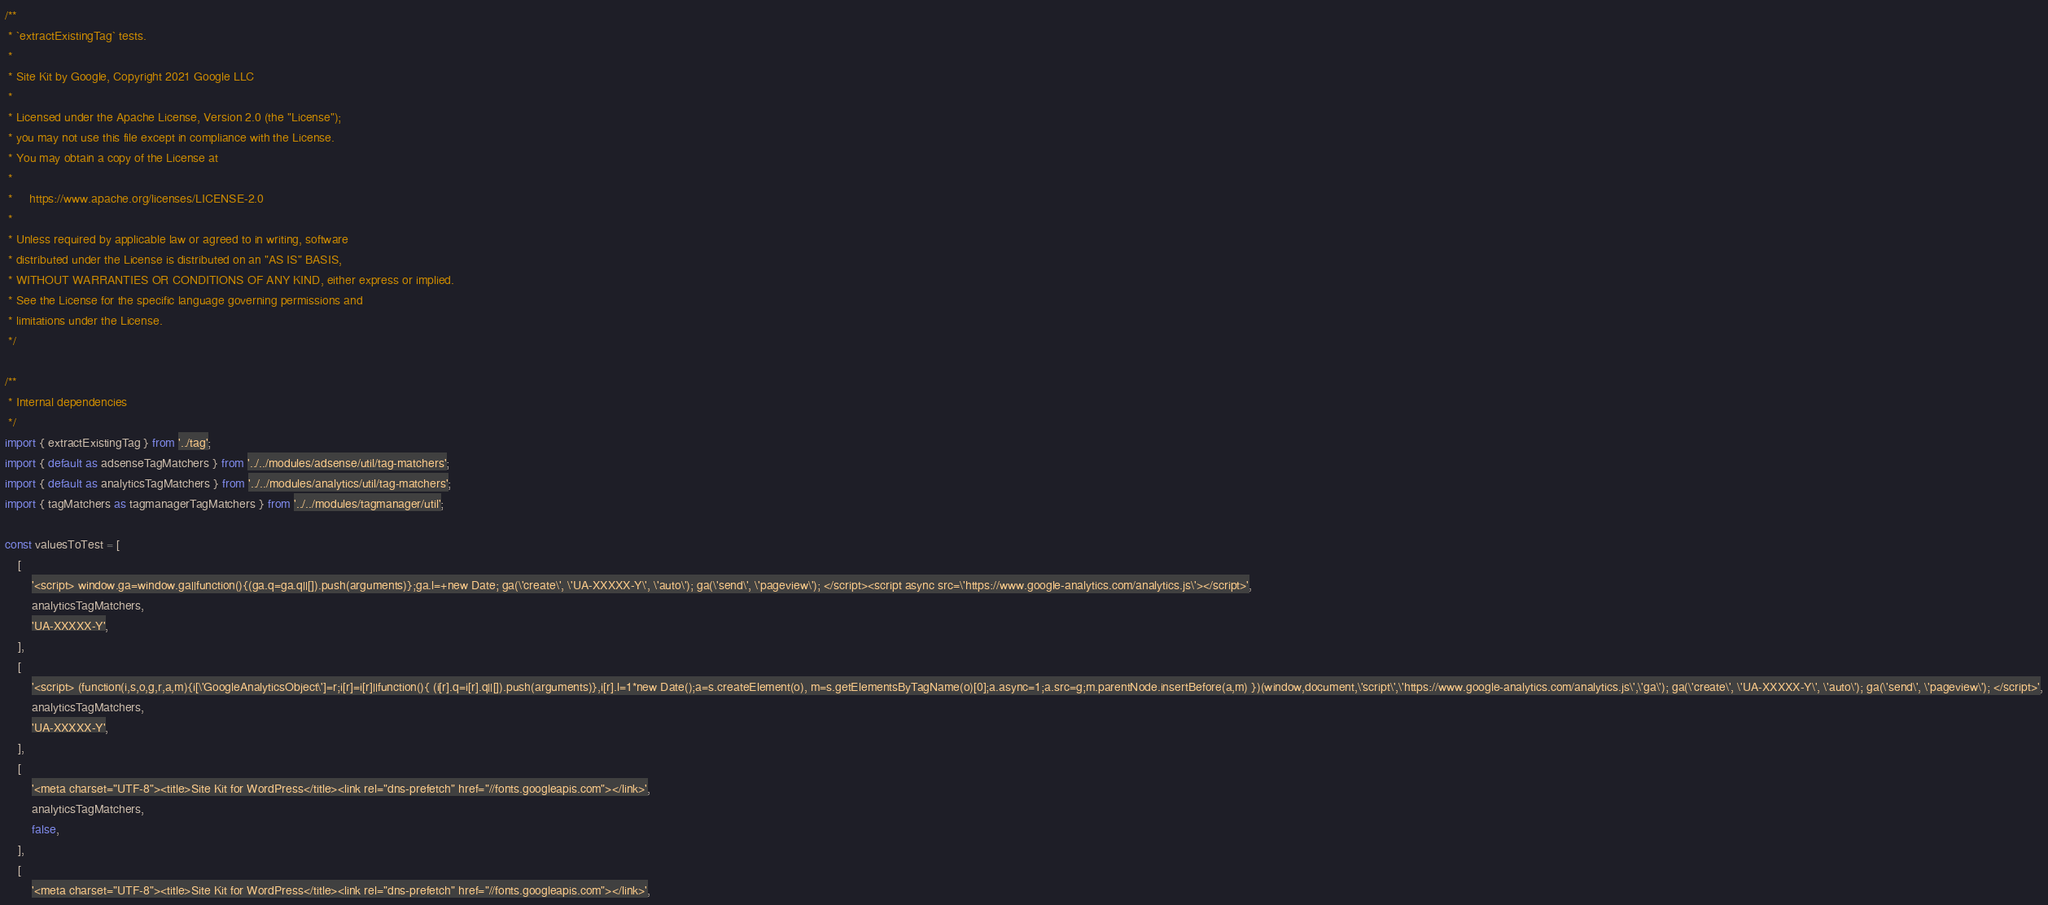<code> <loc_0><loc_0><loc_500><loc_500><_JavaScript_>/**
 * `extractExistingTag` tests.
 *
 * Site Kit by Google, Copyright 2021 Google LLC
 *
 * Licensed under the Apache License, Version 2.0 (the "License");
 * you may not use this file except in compliance with the License.
 * You may obtain a copy of the License at
 *
 *     https://www.apache.org/licenses/LICENSE-2.0
 *
 * Unless required by applicable law or agreed to in writing, software
 * distributed under the License is distributed on an "AS IS" BASIS,
 * WITHOUT WARRANTIES OR CONDITIONS OF ANY KIND, either express or implied.
 * See the License for the specific language governing permissions and
 * limitations under the License.
 */

/**
 * Internal dependencies
 */
import { extractExistingTag } from '../tag';
import { default as adsenseTagMatchers } from '../../modules/adsense/util/tag-matchers';
import { default as analyticsTagMatchers } from '../../modules/analytics/util/tag-matchers';
import { tagMatchers as tagmanagerTagMatchers } from '../../modules/tagmanager/util';

const valuesToTest = [
	[
		'<script> window.ga=window.ga||function(){(ga.q=ga.q||[]).push(arguments)};ga.l=+new Date; ga(\'create\', \'UA-XXXXX-Y\', \'auto\'); ga(\'send\', \'pageview\'); </script><script async src=\'https://www.google-analytics.com/analytics.js\'></script>',
		analyticsTagMatchers,
		'UA-XXXXX-Y',
	],
	[
		'<script> (function(i,s,o,g,r,a,m){i[\'GoogleAnalyticsObject\']=r;i[r]=i[r]||function(){ (i[r].q=i[r].q||[]).push(arguments)},i[r].l=1*new Date();a=s.createElement(o), m=s.getElementsByTagName(o)[0];a.async=1;a.src=g;m.parentNode.insertBefore(a,m) })(window,document,\'script\',\'https://www.google-analytics.com/analytics.js\',\'ga\'); ga(\'create\', \'UA-XXXXX-Y\', \'auto\'); ga(\'send\', \'pageview\'); </script>',
		analyticsTagMatchers,
		'UA-XXXXX-Y',
	],
	[
		'<meta charset="UTF-8"><title>Site Kit for WordPress</title><link rel="dns-prefetch" href="//fonts.googleapis.com"></link>',
		analyticsTagMatchers,
		false,
	],
	[
		'<meta charset="UTF-8"><title>Site Kit for WordPress</title><link rel="dns-prefetch" href="//fonts.googleapis.com"></link>',</code> 